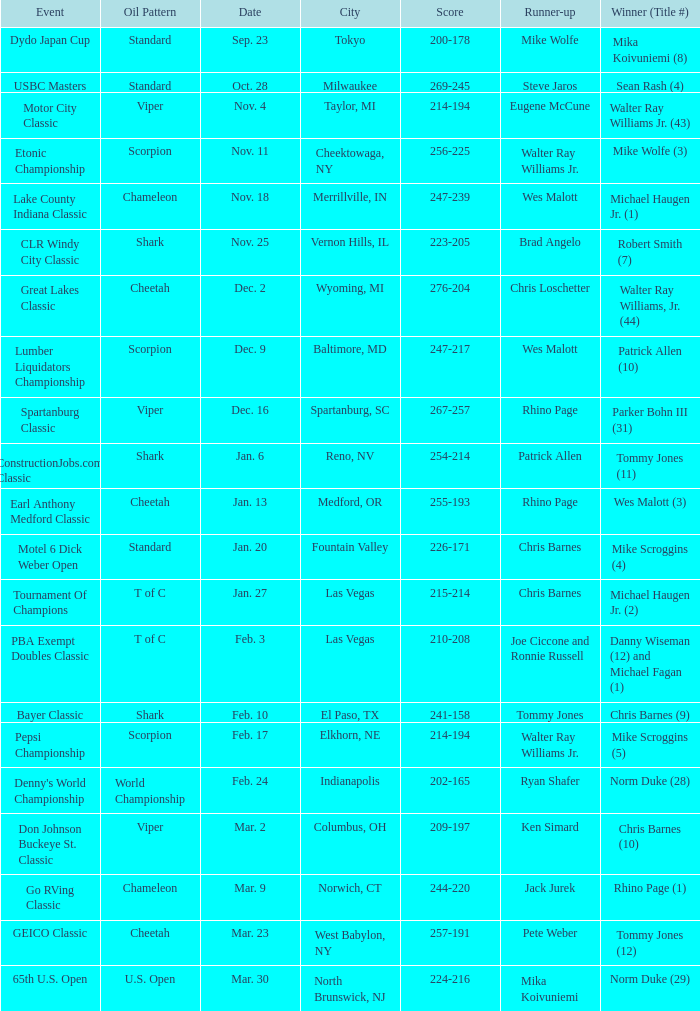Name the Event which has a Score of 209-197? Don Johnson Buckeye St. Classic. 